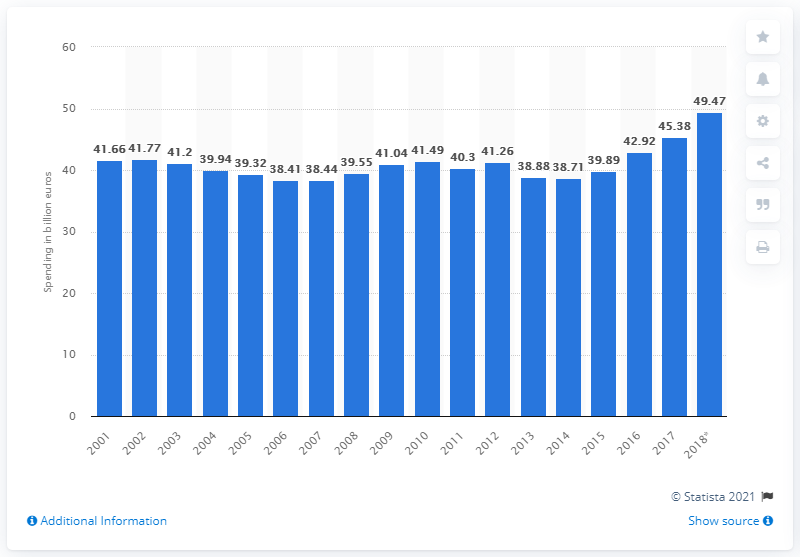Specify some key components in this picture. In 2018, Germany's military spending was 49.47 billion. 